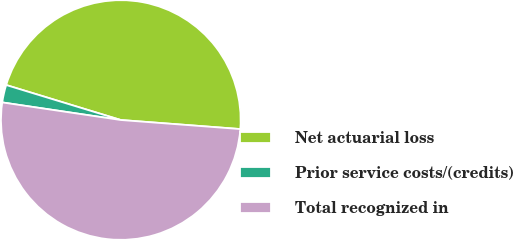Convert chart to OTSL. <chart><loc_0><loc_0><loc_500><loc_500><pie_chart><fcel>Net actuarial loss<fcel>Prior service costs/(credits)<fcel>Total recognized in<nl><fcel>46.49%<fcel>2.37%<fcel>51.14%<nl></chart> 